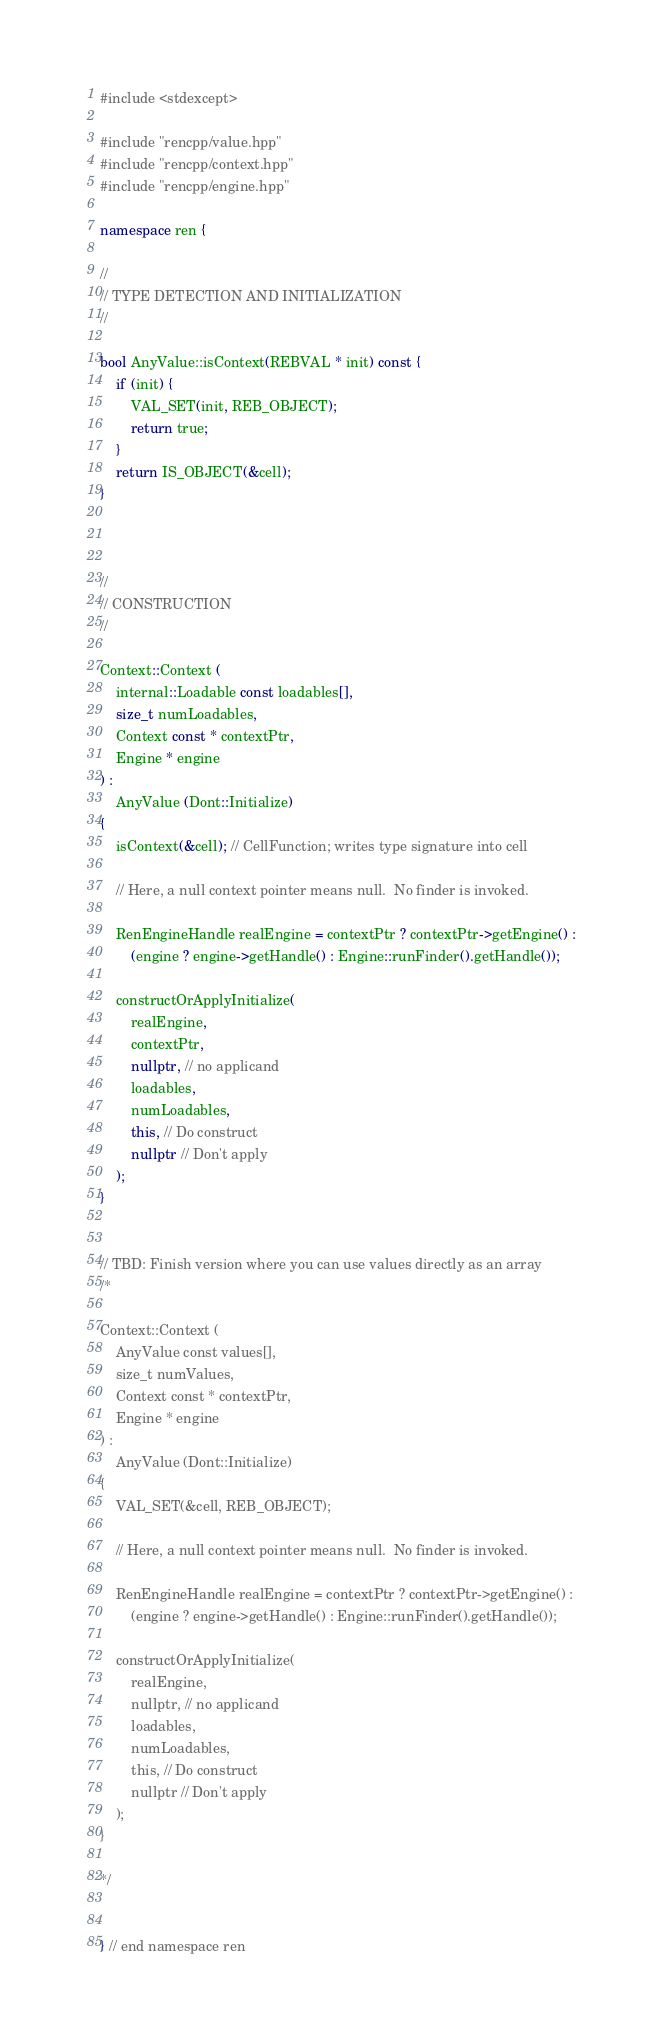<code> <loc_0><loc_0><loc_500><loc_500><_C++_>#include <stdexcept>

#include "rencpp/value.hpp"
#include "rencpp/context.hpp"
#include "rencpp/engine.hpp"

namespace ren {

//
// TYPE DETECTION AND INITIALIZATION
//

bool AnyValue::isContext(REBVAL * init) const {
    if (init) {
        VAL_SET(init, REB_OBJECT);
        return true;
    }
    return IS_OBJECT(&cell);
}



//
// CONSTRUCTION
//

Context::Context (
    internal::Loadable const loadables[],
    size_t numLoadables,
    Context const * contextPtr,
    Engine * engine
) :
    AnyValue (Dont::Initialize)
{
    isContext(&cell); // CellFunction; writes type signature into cell

    // Here, a null context pointer means null.  No finder is invoked.

    RenEngineHandle realEngine = contextPtr ? contextPtr->getEngine() :
        (engine ? engine->getHandle() : Engine::runFinder().getHandle());

    constructOrApplyInitialize(
        realEngine,
        contextPtr,
        nullptr, // no applicand
        loadables,
        numLoadables,
        this, // Do construct
        nullptr // Don't apply
    );
}


// TBD: Finish version where you can use values directly as an array
/*

Context::Context (
    AnyValue const values[],
    size_t numValues,
    Context const * contextPtr,
    Engine * engine
) :
    AnyValue (Dont::Initialize)
{
    VAL_SET(&cell, REB_OBJECT);

    // Here, a null context pointer means null.  No finder is invoked.

    RenEngineHandle realEngine = contextPtr ? contextPtr->getEngine() :
        (engine ? engine->getHandle() : Engine::runFinder().getHandle());

    constructOrApplyInitialize(
        realEngine,
        nullptr, // no applicand
        loadables,
        numLoadables,
        this, // Do construct
        nullptr // Don't apply
    );
}

*/


} // end namespace ren
</code> 